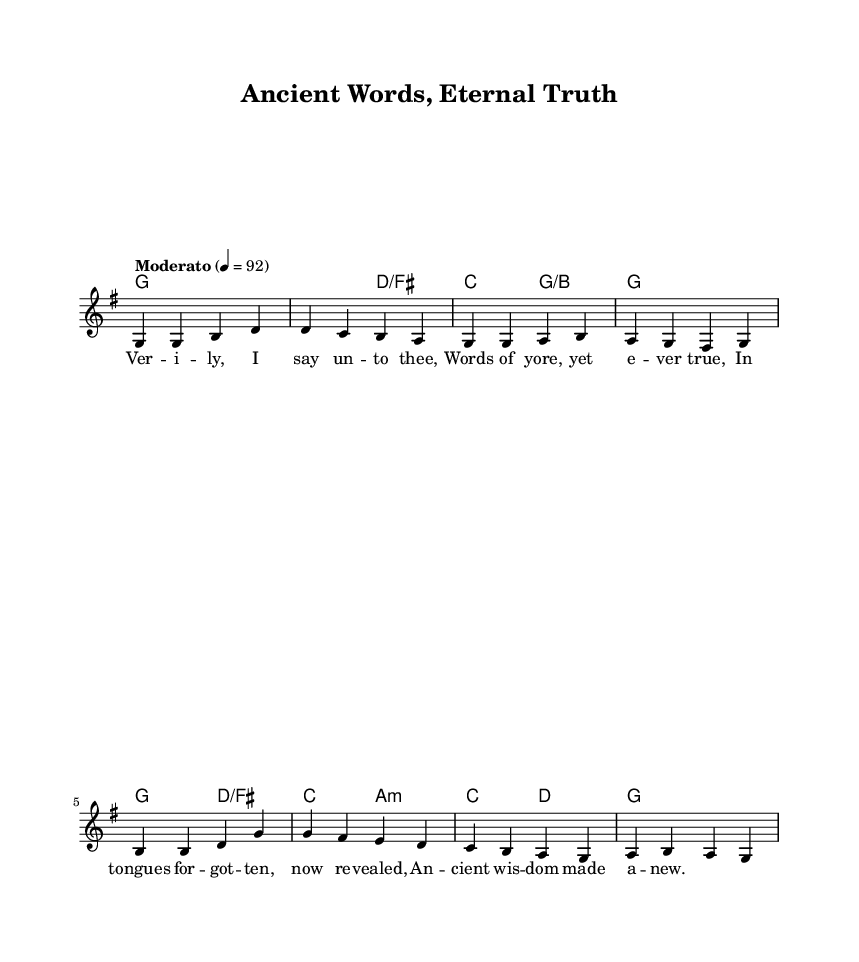What is the key signature of this music? The key signature is indicated by the number of sharps or flats at the beginning of the staff. Here, we see one sharp, indicating that the music is in G major.
Answer: G major What is the time signature of this piece? The time signature appears at the beginning of the staff. It is expressed as a fraction, where the top number indicates how many beats are in a measure, and the bottom number indicates the note length that gets the beat. Here, it shows 4/4, meaning there are four beats per measure.
Answer: 4/4 What is the tempo marking for this hymn? The tempo marking is typically positioned near the beginning of the score. Here, it reads "Moderato" with a metronome marking of 92, suggesting a moderate pace at which the piece should be played.
Answer: Moderato 92 How many measures are in the melody? To determine the number of measures, we count the distinct groupings of beats as delineated by vertical bar lines. There are 8 measures in the provided melody, each containing a series of notes.
Answer: 8 What is the name of this hymn? The title of the hymn is usually found near the top of the score, and here it is stated as "Ancient Words, Eternal Truth." This title reflects the theme of the piece.
Answer: Ancient Words, Eternal Truth Which chord is played at the start of the music? The first chord is noted at the beginning of the chord progression section and is played with the whole note style. It indicates the presence of G major, which can be seen as the tonic of the piece.
Answer: G 